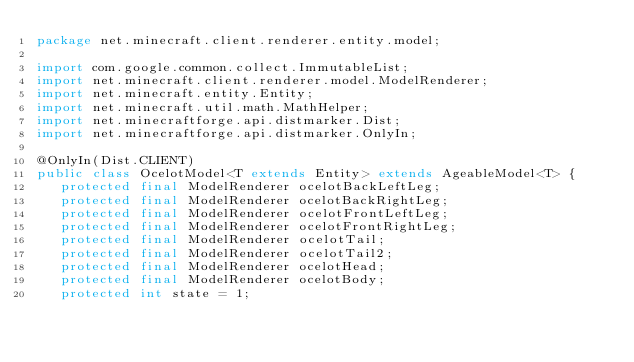<code> <loc_0><loc_0><loc_500><loc_500><_Java_>package net.minecraft.client.renderer.entity.model;

import com.google.common.collect.ImmutableList;
import net.minecraft.client.renderer.model.ModelRenderer;
import net.minecraft.entity.Entity;
import net.minecraft.util.math.MathHelper;
import net.minecraftforge.api.distmarker.Dist;
import net.minecraftforge.api.distmarker.OnlyIn;

@OnlyIn(Dist.CLIENT)
public class OcelotModel<T extends Entity> extends AgeableModel<T> {
   protected final ModelRenderer ocelotBackLeftLeg;
   protected final ModelRenderer ocelotBackRightLeg;
   protected final ModelRenderer ocelotFrontLeftLeg;
   protected final ModelRenderer ocelotFrontRightLeg;
   protected final ModelRenderer ocelotTail;
   protected final ModelRenderer ocelotTail2;
   protected final ModelRenderer ocelotHead;
   protected final ModelRenderer ocelotBody;
   protected int state = 1;
</code> 